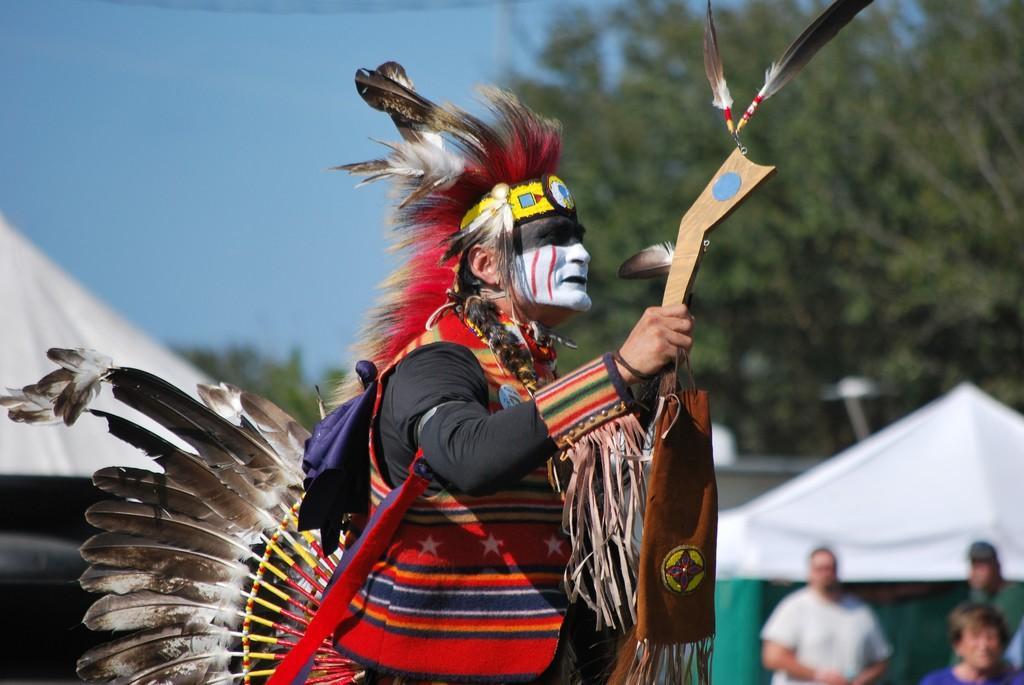Describe this image in one or two sentences. In the center of the image we can see a clown and he is wearing a costume. In the background there are tents and people standing. On the right there is a tree. At the top there is sky. 